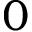<formula> <loc_0><loc_0><loc_500><loc_500>0</formula> 